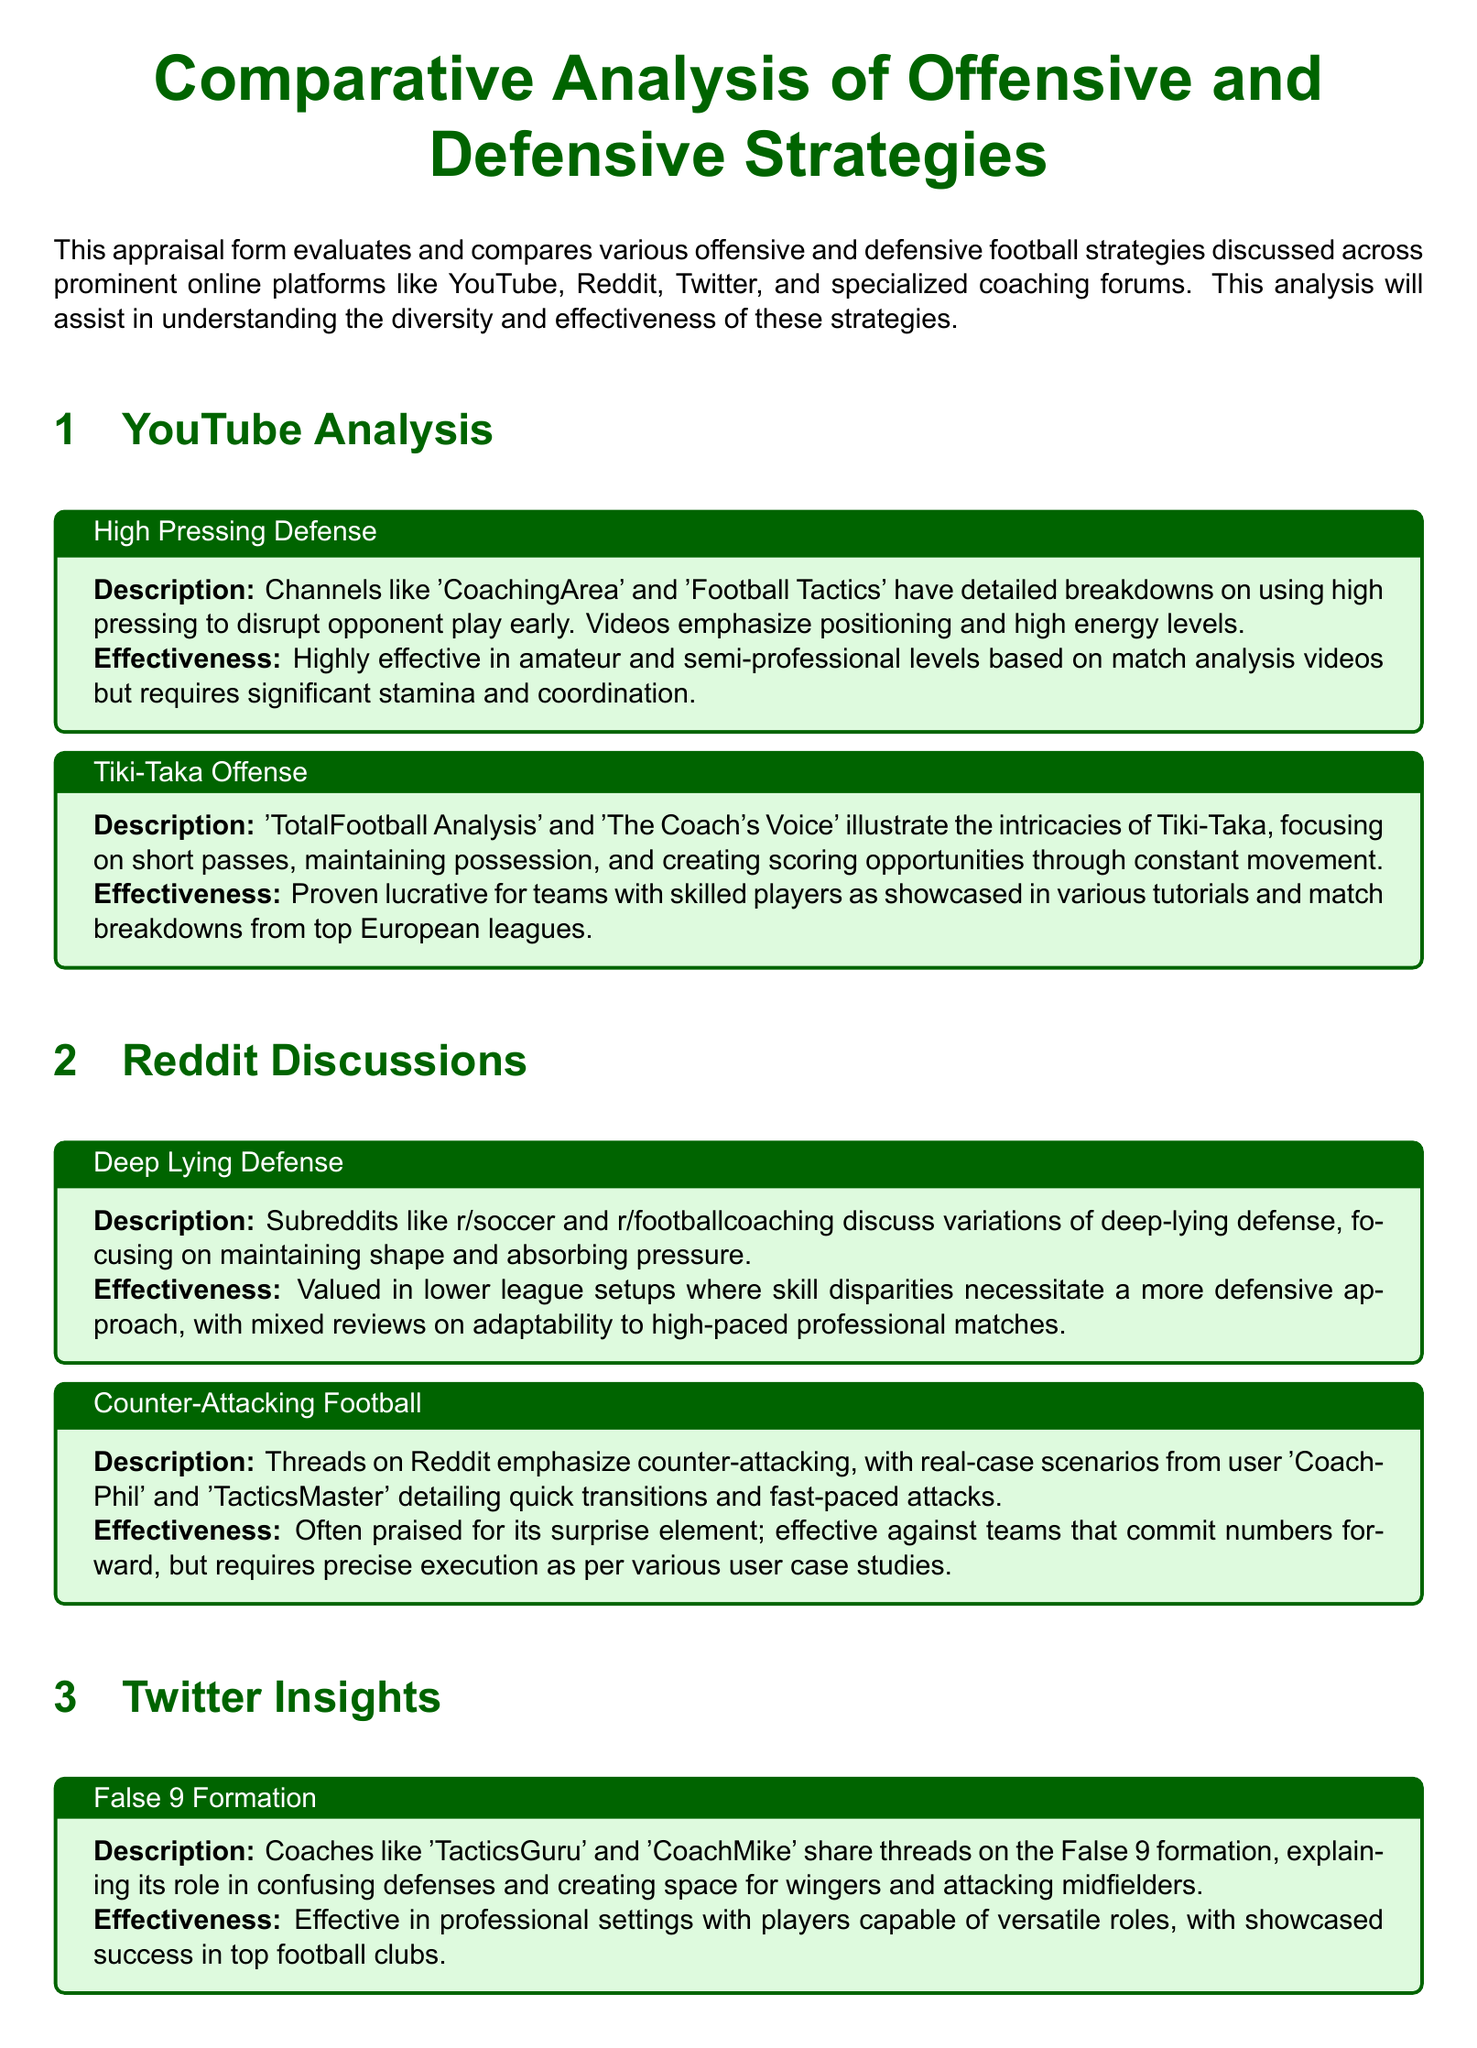What is the focus of the YouTube analysis section? The YouTube analysis section focuses on offensive and defensive strategies in football discussed across prominent online platforms.
Answer: Offensive and defensive strategies How many offensive strategies are discussed in the document? The document discusses a total of four offensive strategies in different sections.
Answer: Four What strategy is mentioned in the Twitter insights section related to formations? The Twitter insights section mentions the False 9 formation strategy.
Answer: False 9 formation Which coaching forum strategy is favored for youth and mid-tier levels? The 4-4-2 diamond formation is favored for youth and mid-tier levels in the specialized coaching forums.
Answer: 4-4-2 diamond formation What type of defense is emphasized in the Reddit discussions? The Reddit discussions emphasize the Deep Lying Defense strategy.
Answer: Deep Lying Defense Which strategy is shown to be effective against teams committing numbers forward? The Counter-Attacking Football strategy is shown to be effective against teams committing numbers forward.
Answer: Counter-Attacking Football What are the channels highlighted for discussing High Pressing Defense on YouTube? Channels like 'CoachingArea' and 'Football Tactics' are highlighted for discussing High Pressing Defense on YouTube.
Answer: CoachingArea and Football Tactics What does the conclusion of the document emphasize? The conclusion emphasizes understanding the intricate details and real-world applications of the strategies to enhance a coach's arsenal.
Answer: Enhancing a coach's arsenal 